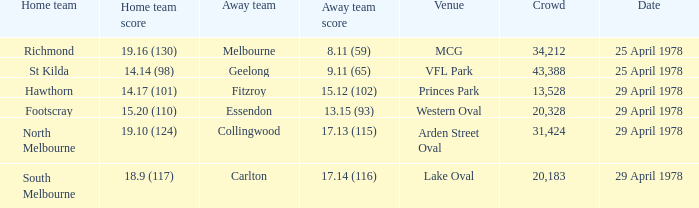Which team played as the home side at mcg? Richmond. 